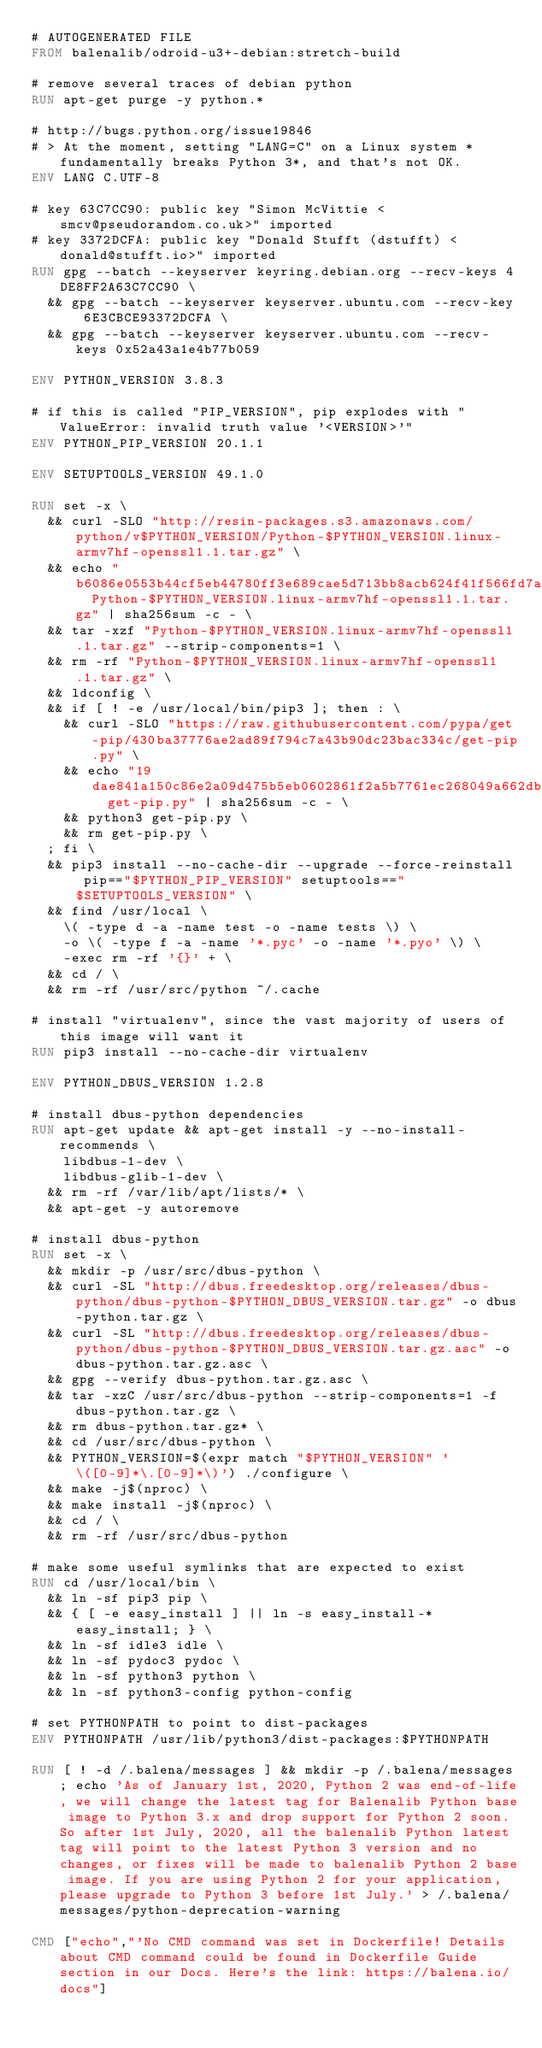Convert code to text. <code><loc_0><loc_0><loc_500><loc_500><_Dockerfile_># AUTOGENERATED FILE
FROM balenalib/odroid-u3+-debian:stretch-build

# remove several traces of debian python
RUN apt-get purge -y python.*

# http://bugs.python.org/issue19846
# > At the moment, setting "LANG=C" on a Linux system *fundamentally breaks Python 3*, and that's not OK.
ENV LANG C.UTF-8

# key 63C7CC90: public key "Simon McVittie <smcv@pseudorandom.co.uk>" imported
# key 3372DCFA: public key "Donald Stufft (dstufft) <donald@stufft.io>" imported
RUN gpg --batch --keyserver keyring.debian.org --recv-keys 4DE8FF2A63C7CC90 \
	&& gpg --batch --keyserver keyserver.ubuntu.com --recv-key 6E3CBCE93372DCFA \
	&& gpg --batch --keyserver keyserver.ubuntu.com --recv-keys 0x52a43a1e4b77b059

ENV PYTHON_VERSION 3.8.3

# if this is called "PIP_VERSION", pip explodes with "ValueError: invalid truth value '<VERSION>'"
ENV PYTHON_PIP_VERSION 20.1.1

ENV SETUPTOOLS_VERSION 49.1.0

RUN set -x \
	&& curl -SLO "http://resin-packages.s3.amazonaws.com/python/v$PYTHON_VERSION/Python-$PYTHON_VERSION.linux-armv7hf-openssl1.1.tar.gz" \
	&& echo "b6086e0553b44cf5eb44780ff3e689cae5d713bb8acb624f41f566fd7a4b19df  Python-$PYTHON_VERSION.linux-armv7hf-openssl1.1.tar.gz" | sha256sum -c - \
	&& tar -xzf "Python-$PYTHON_VERSION.linux-armv7hf-openssl1.1.tar.gz" --strip-components=1 \
	&& rm -rf "Python-$PYTHON_VERSION.linux-armv7hf-openssl1.1.tar.gz" \
	&& ldconfig \
	&& if [ ! -e /usr/local/bin/pip3 ]; then : \
		&& curl -SLO "https://raw.githubusercontent.com/pypa/get-pip/430ba37776ae2ad89f794c7a43b90dc23bac334c/get-pip.py" \
		&& echo "19dae841a150c86e2a09d475b5eb0602861f2a5b7761ec268049a662dbd2bd0c  get-pip.py" | sha256sum -c - \
		&& python3 get-pip.py \
		&& rm get-pip.py \
	; fi \
	&& pip3 install --no-cache-dir --upgrade --force-reinstall pip=="$PYTHON_PIP_VERSION" setuptools=="$SETUPTOOLS_VERSION" \
	&& find /usr/local \
		\( -type d -a -name test -o -name tests \) \
		-o \( -type f -a -name '*.pyc' -o -name '*.pyo' \) \
		-exec rm -rf '{}' + \
	&& cd / \
	&& rm -rf /usr/src/python ~/.cache

# install "virtualenv", since the vast majority of users of this image will want it
RUN pip3 install --no-cache-dir virtualenv

ENV PYTHON_DBUS_VERSION 1.2.8

# install dbus-python dependencies 
RUN apt-get update && apt-get install -y --no-install-recommends \
		libdbus-1-dev \
		libdbus-glib-1-dev \
	&& rm -rf /var/lib/apt/lists/* \
	&& apt-get -y autoremove

# install dbus-python
RUN set -x \
	&& mkdir -p /usr/src/dbus-python \
	&& curl -SL "http://dbus.freedesktop.org/releases/dbus-python/dbus-python-$PYTHON_DBUS_VERSION.tar.gz" -o dbus-python.tar.gz \
	&& curl -SL "http://dbus.freedesktop.org/releases/dbus-python/dbus-python-$PYTHON_DBUS_VERSION.tar.gz.asc" -o dbus-python.tar.gz.asc \
	&& gpg --verify dbus-python.tar.gz.asc \
	&& tar -xzC /usr/src/dbus-python --strip-components=1 -f dbus-python.tar.gz \
	&& rm dbus-python.tar.gz* \
	&& cd /usr/src/dbus-python \
	&& PYTHON_VERSION=$(expr match "$PYTHON_VERSION" '\([0-9]*\.[0-9]*\)') ./configure \
	&& make -j$(nproc) \
	&& make install -j$(nproc) \
	&& cd / \
	&& rm -rf /usr/src/dbus-python

# make some useful symlinks that are expected to exist
RUN cd /usr/local/bin \
	&& ln -sf pip3 pip \
	&& { [ -e easy_install ] || ln -s easy_install-* easy_install; } \
	&& ln -sf idle3 idle \
	&& ln -sf pydoc3 pydoc \
	&& ln -sf python3 python \
	&& ln -sf python3-config python-config

# set PYTHONPATH to point to dist-packages
ENV PYTHONPATH /usr/lib/python3/dist-packages:$PYTHONPATH

RUN [ ! -d /.balena/messages ] && mkdir -p /.balena/messages; echo 'As of January 1st, 2020, Python 2 was end-of-life, we will change the latest tag for Balenalib Python base image to Python 3.x and drop support for Python 2 soon. So after 1st July, 2020, all the balenalib Python latest tag will point to the latest Python 3 version and no changes, or fixes will be made to balenalib Python 2 base image. If you are using Python 2 for your application, please upgrade to Python 3 before 1st July.' > /.balena/messages/python-deprecation-warning

CMD ["echo","'No CMD command was set in Dockerfile! Details about CMD command could be found in Dockerfile Guide section in our Docs. Here's the link: https://balena.io/docs"]
</code> 